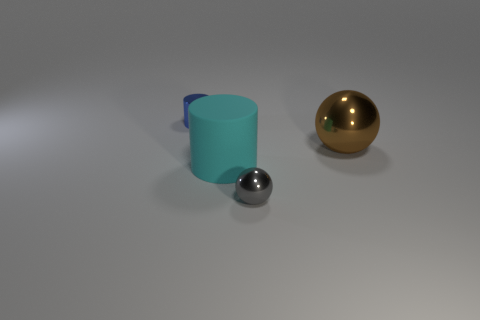Add 2 tiny green matte cylinders. How many objects exist? 6 Subtract all small gray metal objects. Subtract all small blue cylinders. How many objects are left? 2 Add 2 blue shiny objects. How many blue shiny objects are left? 3 Add 1 small rubber cylinders. How many small rubber cylinders exist? 1 Subtract 0 yellow blocks. How many objects are left? 4 